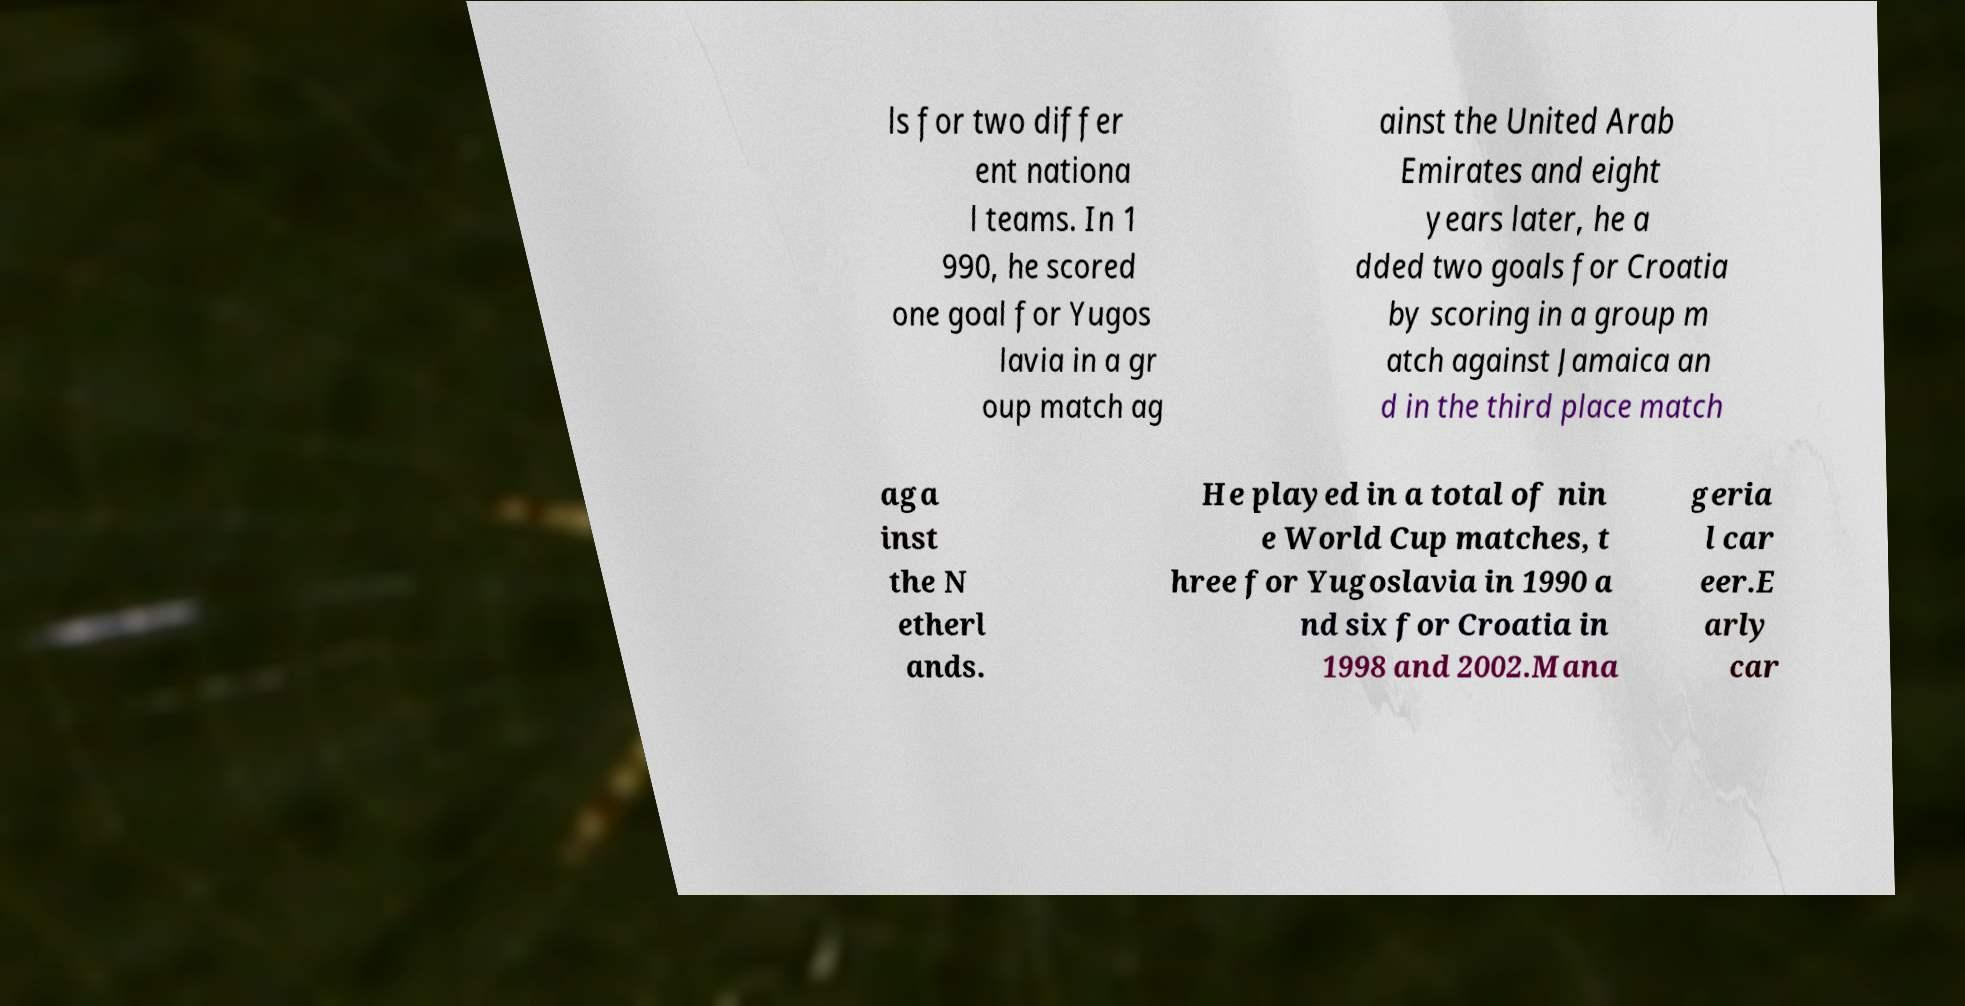Can you read and provide the text displayed in the image?This photo seems to have some interesting text. Can you extract and type it out for me? ls for two differ ent nationa l teams. In 1 990, he scored one goal for Yugos lavia in a gr oup match ag ainst the United Arab Emirates and eight years later, he a dded two goals for Croatia by scoring in a group m atch against Jamaica an d in the third place match aga inst the N etherl ands. He played in a total of nin e World Cup matches, t hree for Yugoslavia in 1990 a nd six for Croatia in 1998 and 2002.Mana geria l car eer.E arly car 